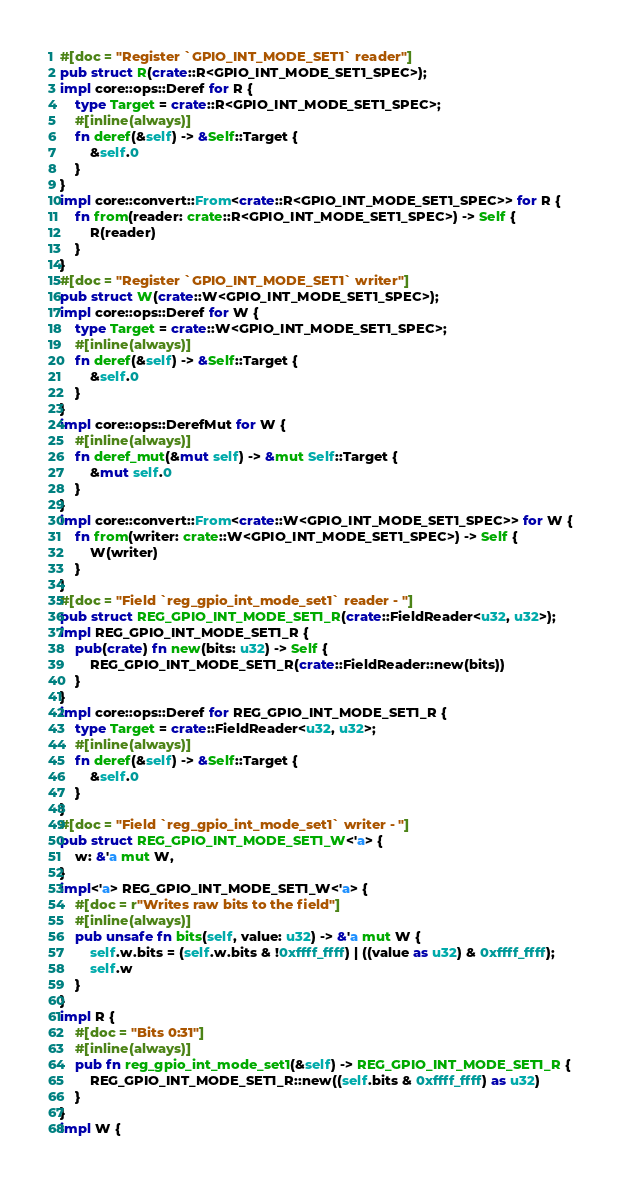Convert code to text. <code><loc_0><loc_0><loc_500><loc_500><_Rust_>#[doc = "Register `GPIO_INT_MODE_SET1` reader"]
pub struct R(crate::R<GPIO_INT_MODE_SET1_SPEC>);
impl core::ops::Deref for R {
    type Target = crate::R<GPIO_INT_MODE_SET1_SPEC>;
    #[inline(always)]
    fn deref(&self) -> &Self::Target {
        &self.0
    }
}
impl core::convert::From<crate::R<GPIO_INT_MODE_SET1_SPEC>> for R {
    fn from(reader: crate::R<GPIO_INT_MODE_SET1_SPEC>) -> Self {
        R(reader)
    }
}
#[doc = "Register `GPIO_INT_MODE_SET1` writer"]
pub struct W(crate::W<GPIO_INT_MODE_SET1_SPEC>);
impl core::ops::Deref for W {
    type Target = crate::W<GPIO_INT_MODE_SET1_SPEC>;
    #[inline(always)]
    fn deref(&self) -> &Self::Target {
        &self.0
    }
}
impl core::ops::DerefMut for W {
    #[inline(always)]
    fn deref_mut(&mut self) -> &mut Self::Target {
        &mut self.0
    }
}
impl core::convert::From<crate::W<GPIO_INT_MODE_SET1_SPEC>> for W {
    fn from(writer: crate::W<GPIO_INT_MODE_SET1_SPEC>) -> Self {
        W(writer)
    }
}
#[doc = "Field `reg_gpio_int_mode_set1` reader - "]
pub struct REG_GPIO_INT_MODE_SET1_R(crate::FieldReader<u32, u32>);
impl REG_GPIO_INT_MODE_SET1_R {
    pub(crate) fn new(bits: u32) -> Self {
        REG_GPIO_INT_MODE_SET1_R(crate::FieldReader::new(bits))
    }
}
impl core::ops::Deref for REG_GPIO_INT_MODE_SET1_R {
    type Target = crate::FieldReader<u32, u32>;
    #[inline(always)]
    fn deref(&self) -> &Self::Target {
        &self.0
    }
}
#[doc = "Field `reg_gpio_int_mode_set1` writer - "]
pub struct REG_GPIO_INT_MODE_SET1_W<'a> {
    w: &'a mut W,
}
impl<'a> REG_GPIO_INT_MODE_SET1_W<'a> {
    #[doc = r"Writes raw bits to the field"]
    #[inline(always)]
    pub unsafe fn bits(self, value: u32) -> &'a mut W {
        self.w.bits = (self.w.bits & !0xffff_ffff) | ((value as u32) & 0xffff_ffff);
        self.w
    }
}
impl R {
    #[doc = "Bits 0:31"]
    #[inline(always)]
    pub fn reg_gpio_int_mode_set1(&self) -> REG_GPIO_INT_MODE_SET1_R {
        REG_GPIO_INT_MODE_SET1_R::new((self.bits & 0xffff_ffff) as u32)
    }
}
impl W {</code> 